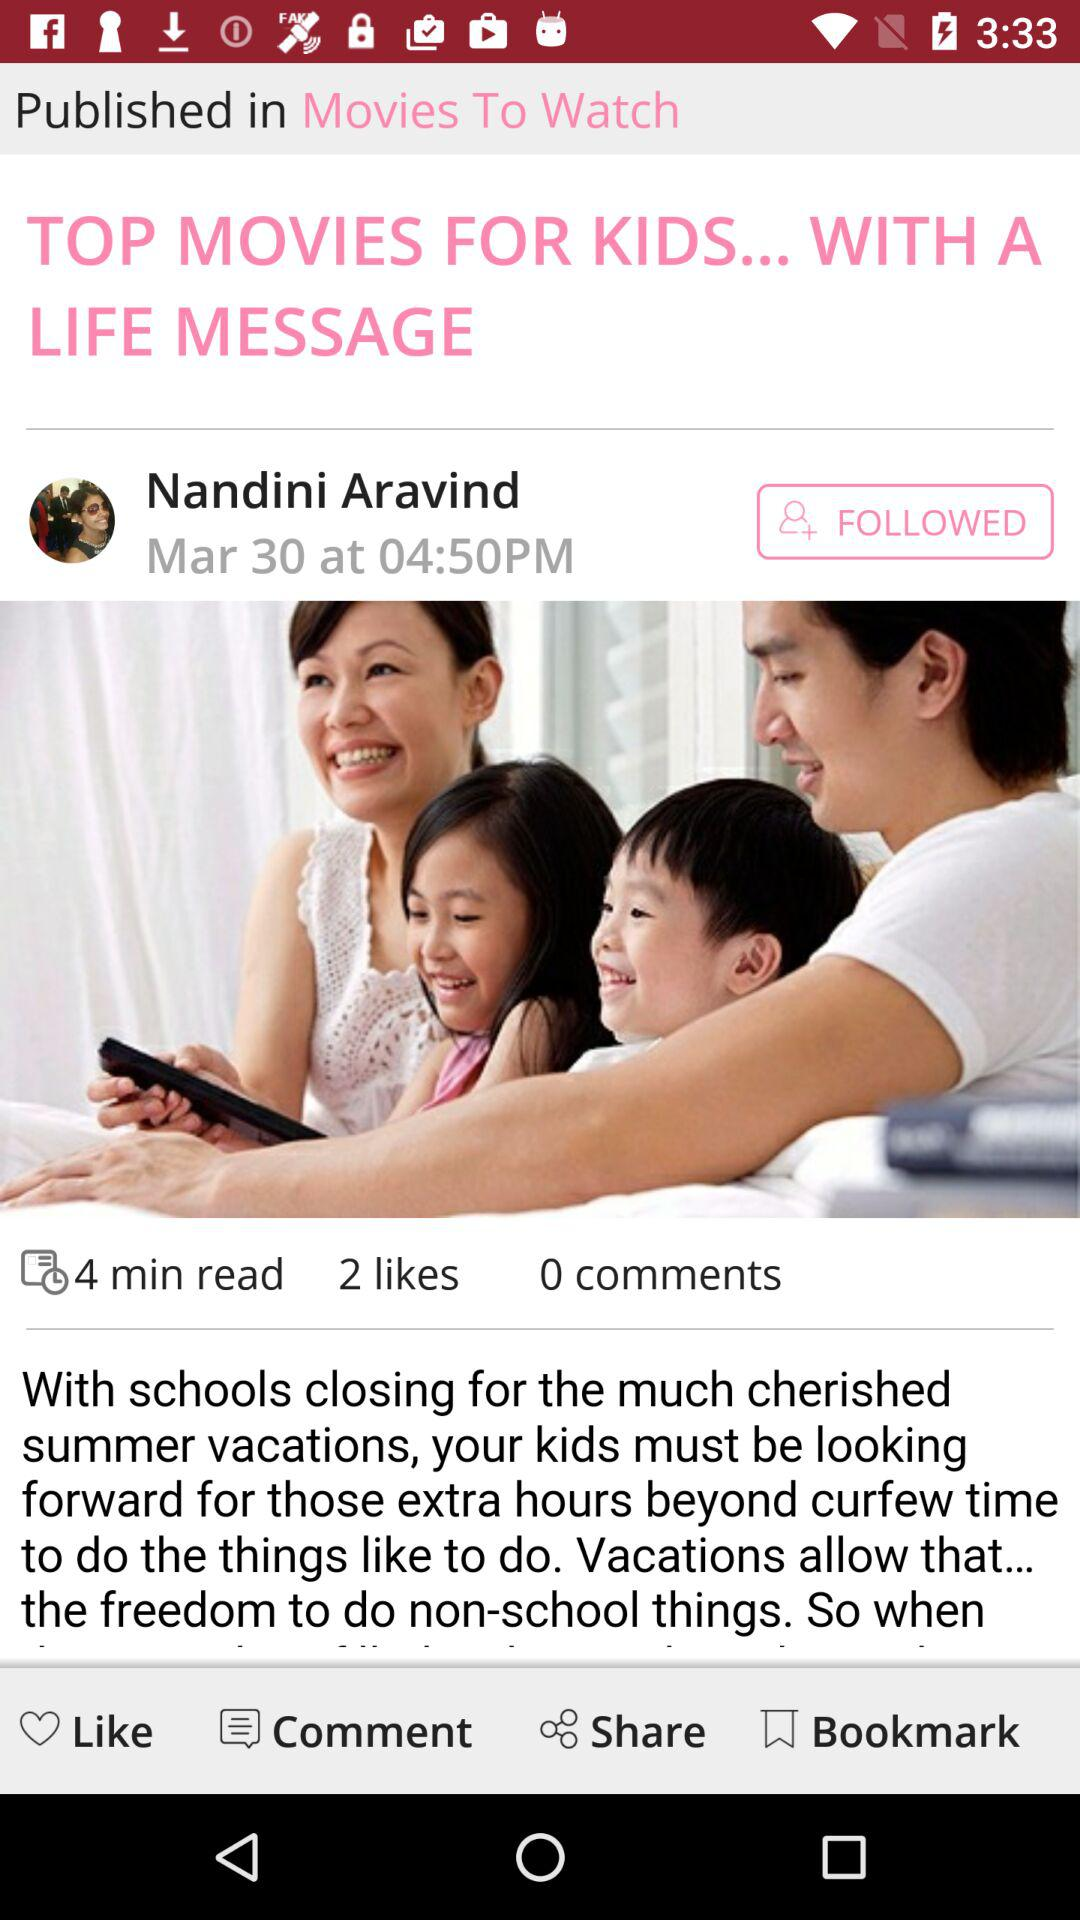What is the count of comments? The count of comments is 0. 